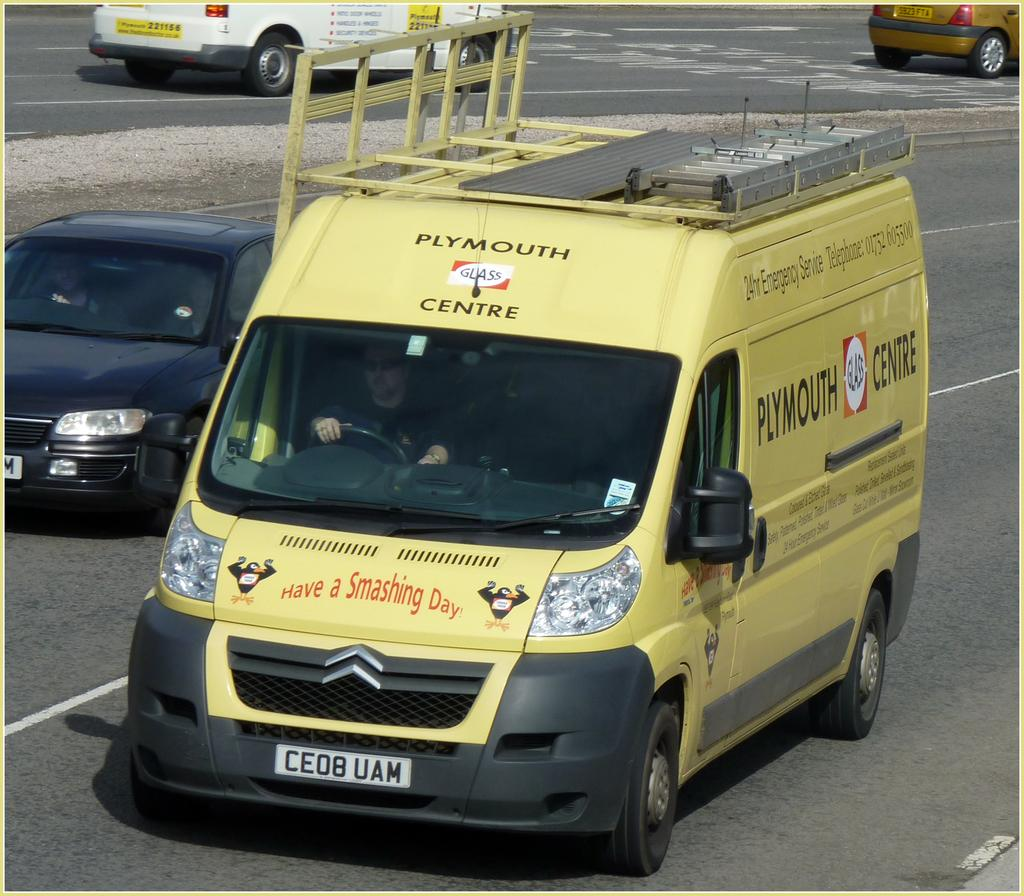What can be seen on the road in the image? There are vehicles on the road in the image. Can you describe one of the vehicles in the image? A yellow van is present in the image. Who or what is inside the yellow van? A person is sitting inside the yellow van. What can be seen on the road that might help with traffic organization? White lines are visible on the road in the image. What type of quill is the person in the yellow van using to write a letter? There is no quill present in the image, nor is there any indication that the person is writing a letter. 